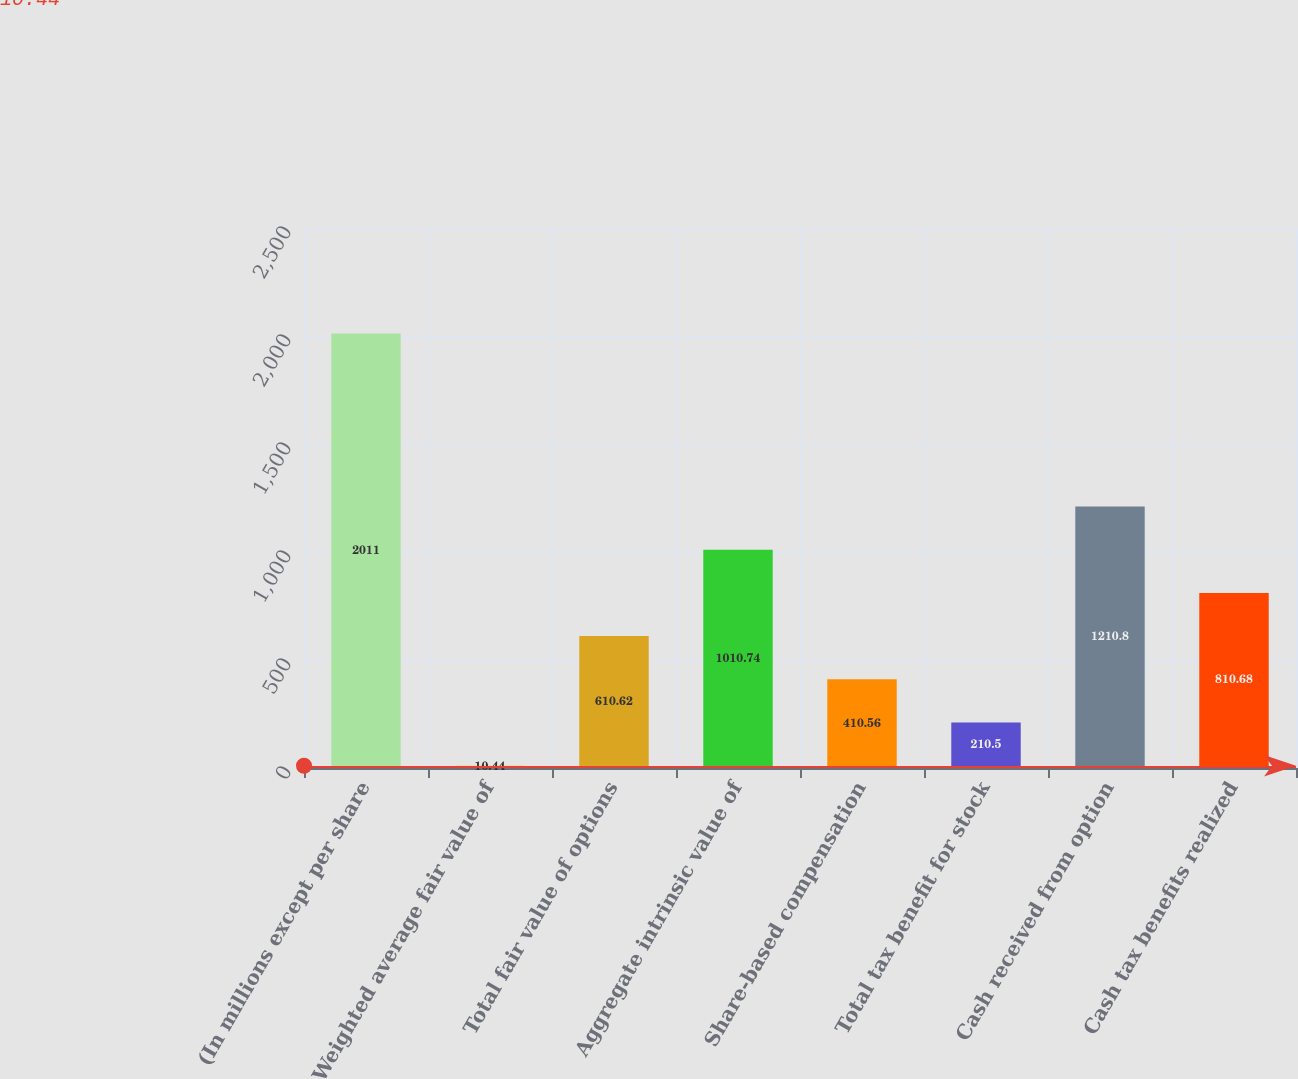<chart> <loc_0><loc_0><loc_500><loc_500><bar_chart><fcel>(In millions except per share<fcel>Weighted average fair value of<fcel>Total fair value of options<fcel>Aggregate intrinsic value of<fcel>Share-based compensation<fcel>Total tax benefit for stock<fcel>Cash received from option<fcel>Cash tax benefits realized<nl><fcel>2011<fcel>10.44<fcel>610.62<fcel>1010.74<fcel>410.56<fcel>210.5<fcel>1210.8<fcel>810.68<nl></chart> 